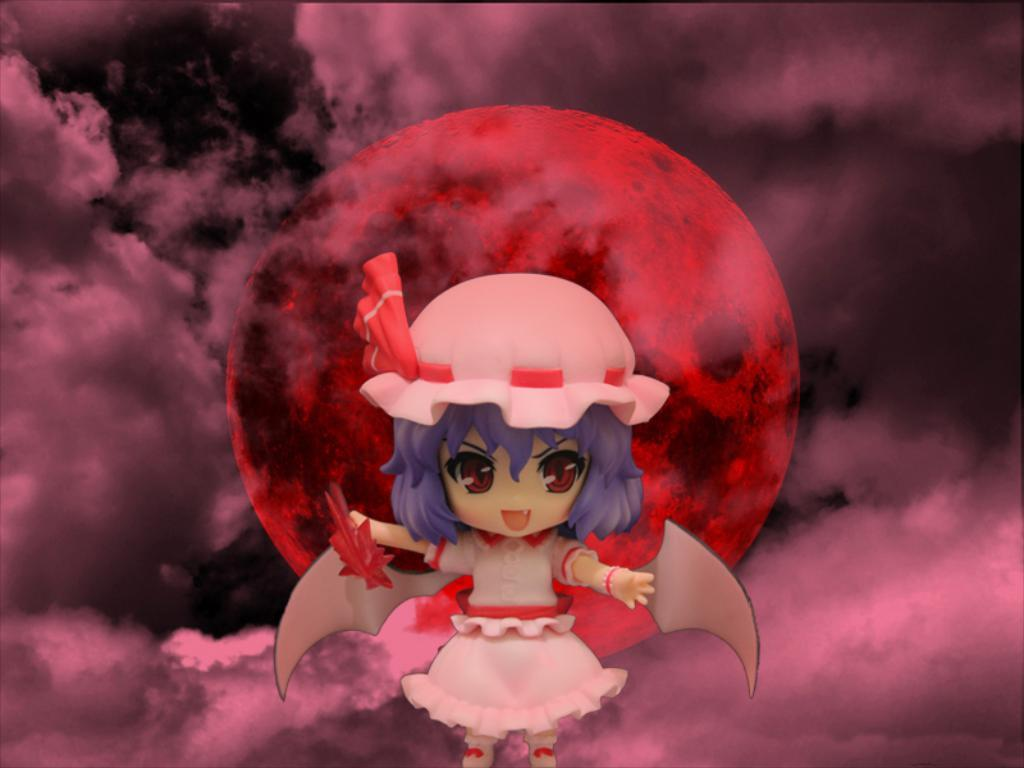What is the main subject of the image? There is a cartoon of a girl in the image. What distinguishing feature does the girl have? The girl has wings. How would you describe the sky in the background of the image? The sky in the background is cloudy and dark. Can you describe the sun in the image? The sun in the image is orange. Does the girl's brother appear in the image? There is no mention of a brother in the image, so we cannot determine if he is present. What type of art is the girl creating in the image? The image does not depict the girl creating any art; it simply shows her with wings in a cloudy, dark sky with an orange sun. 